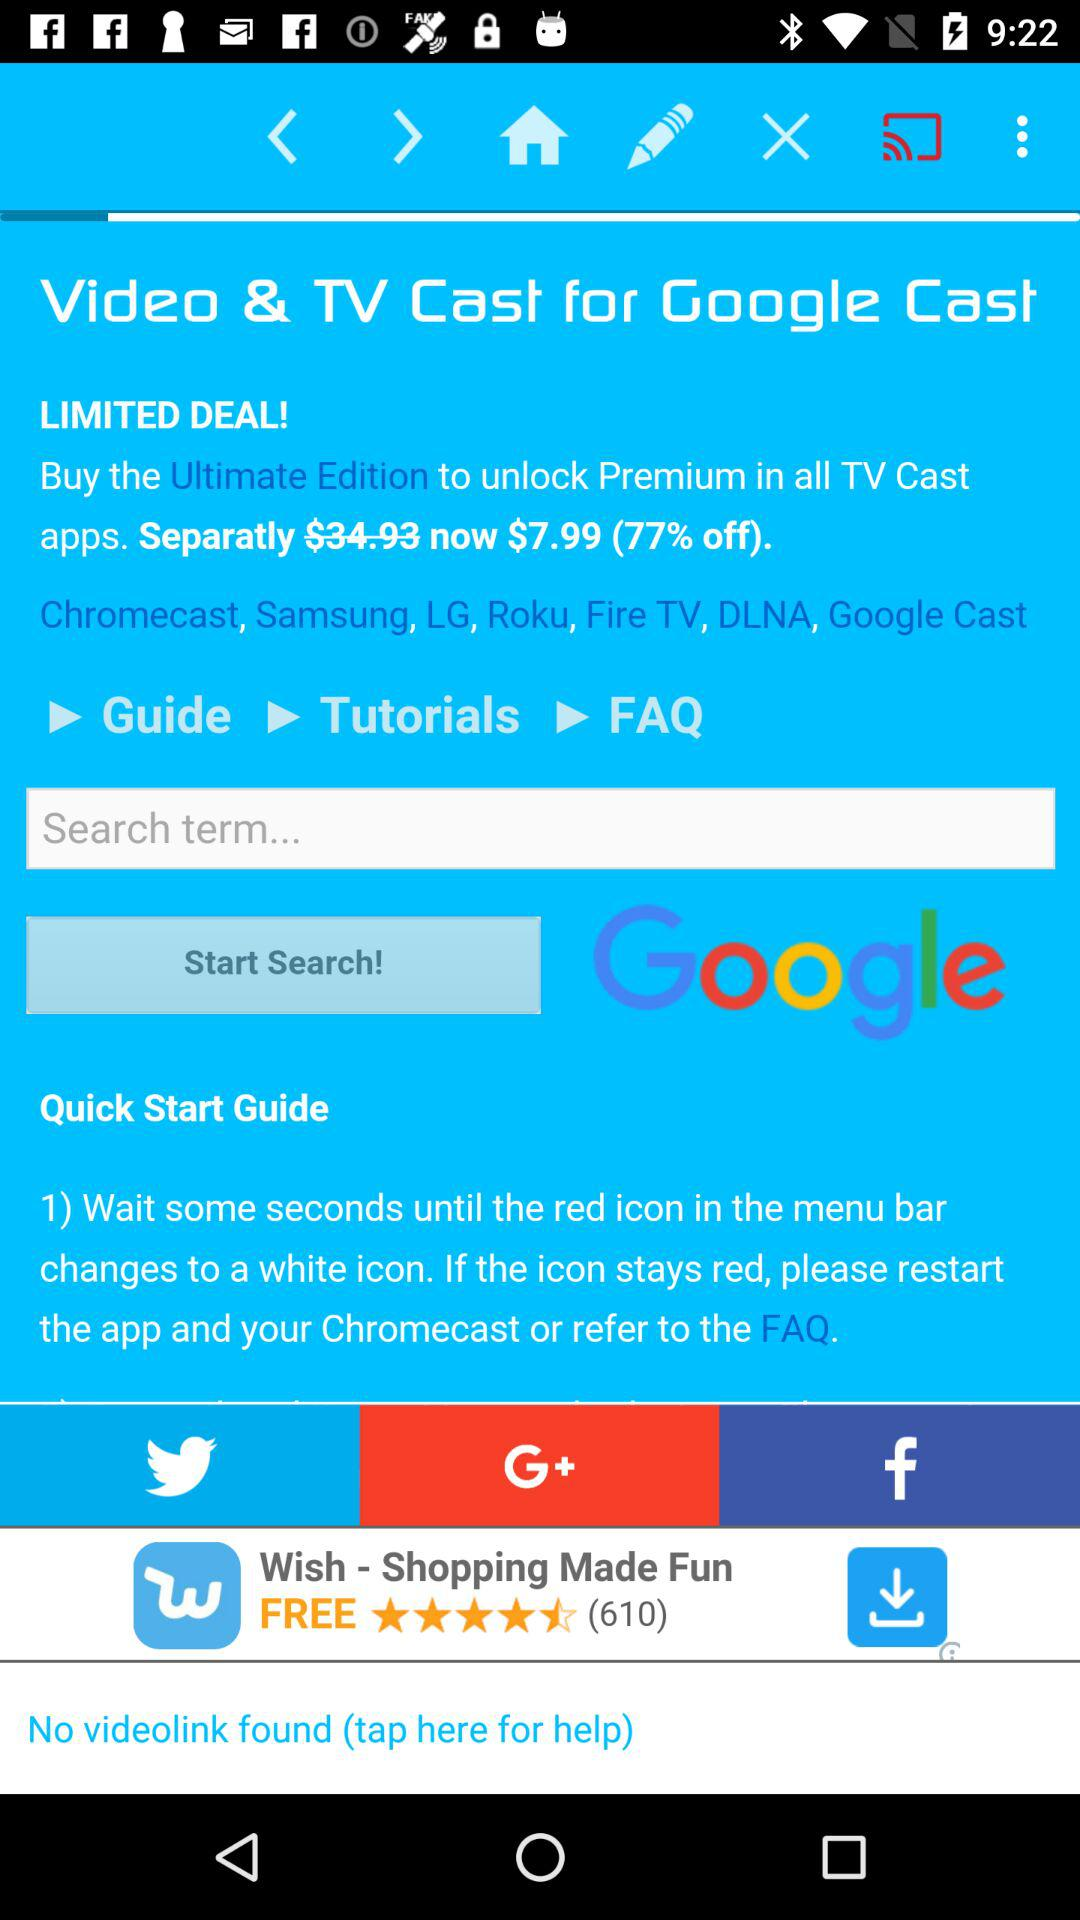What are the available premium apps for tv cast?
When the provided information is insufficient, respond with <no answer>. <no answer> 